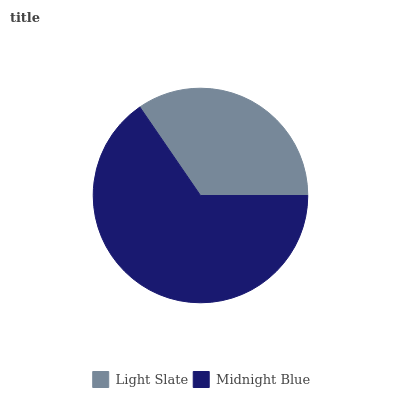Is Light Slate the minimum?
Answer yes or no. Yes. Is Midnight Blue the maximum?
Answer yes or no. Yes. Is Midnight Blue the minimum?
Answer yes or no. No. Is Midnight Blue greater than Light Slate?
Answer yes or no. Yes. Is Light Slate less than Midnight Blue?
Answer yes or no. Yes. Is Light Slate greater than Midnight Blue?
Answer yes or no. No. Is Midnight Blue less than Light Slate?
Answer yes or no. No. Is Midnight Blue the high median?
Answer yes or no. Yes. Is Light Slate the low median?
Answer yes or no. Yes. Is Light Slate the high median?
Answer yes or no. No. Is Midnight Blue the low median?
Answer yes or no. No. 